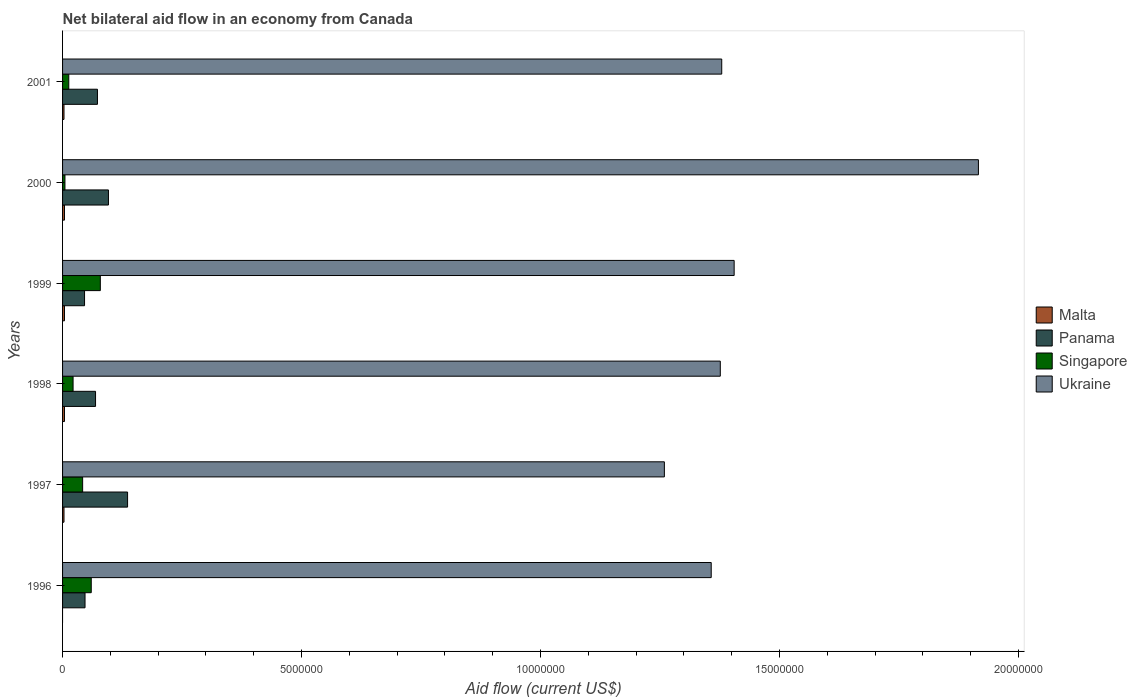How many different coloured bars are there?
Your answer should be very brief. 4. Are the number of bars per tick equal to the number of legend labels?
Keep it short and to the point. No. How many bars are there on the 4th tick from the bottom?
Your answer should be compact. 4. What is the label of the 3rd group of bars from the top?
Ensure brevity in your answer.  1999. Across all years, what is the minimum net bilateral aid flow in Ukraine?
Make the answer very short. 1.26e+07. What is the total net bilateral aid flow in Ukraine in the graph?
Make the answer very short. 8.69e+07. What is the difference between the net bilateral aid flow in Panama in 1996 and the net bilateral aid flow in Malta in 2000?
Make the answer very short. 4.30e+05. In the year 1998, what is the difference between the net bilateral aid flow in Ukraine and net bilateral aid flow in Panama?
Your answer should be very brief. 1.31e+07. In how many years, is the net bilateral aid flow in Malta greater than 4000000 US$?
Offer a very short reply. 0. What is the ratio of the net bilateral aid flow in Ukraine in 1999 to that in 2000?
Give a very brief answer. 0.73. Is the net bilateral aid flow in Malta in 1997 less than that in 1999?
Ensure brevity in your answer.  Yes. What is the difference between the highest and the lowest net bilateral aid flow in Panama?
Offer a very short reply. 9.00e+05. Is it the case that in every year, the sum of the net bilateral aid flow in Panama and net bilateral aid flow in Malta is greater than the sum of net bilateral aid flow in Ukraine and net bilateral aid flow in Singapore?
Make the answer very short. No. Is it the case that in every year, the sum of the net bilateral aid flow in Ukraine and net bilateral aid flow in Singapore is greater than the net bilateral aid flow in Malta?
Offer a terse response. Yes. Are all the bars in the graph horizontal?
Keep it short and to the point. Yes. How many years are there in the graph?
Your answer should be very brief. 6. Does the graph contain any zero values?
Give a very brief answer. Yes. Does the graph contain grids?
Your response must be concise. No. How are the legend labels stacked?
Provide a short and direct response. Vertical. What is the title of the graph?
Make the answer very short. Net bilateral aid flow in an economy from Canada. Does "Panama" appear as one of the legend labels in the graph?
Offer a terse response. Yes. What is the label or title of the X-axis?
Make the answer very short. Aid flow (current US$). What is the label or title of the Y-axis?
Your answer should be compact. Years. What is the Aid flow (current US$) of Malta in 1996?
Make the answer very short. 0. What is the Aid flow (current US$) of Panama in 1996?
Your response must be concise. 4.70e+05. What is the Aid flow (current US$) in Singapore in 1996?
Keep it short and to the point. 6.00e+05. What is the Aid flow (current US$) of Ukraine in 1996?
Your response must be concise. 1.36e+07. What is the Aid flow (current US$) of Malta in 1997?
Ensure brevity in your answer.  3.00e+04. What is the Aid flow (current US$) of Panama in 1997?
Provide a succinct answer. 1.36e+06. What is the Aid flow (current US$) in Singapore in 1997?
Provide a short and direct response. 4.20e+05. What is the Aid flow (current US$) of Ukraine in 1997?
Your answer should be very brief. 1.26e+07. What is the Aid flow (current US$) of Panama in 1998?
Your answer should be compact. 6.90e+05. What is the Aid flow (current US$) in Ukraine in 1998?
Offer a very short reply. 1.38e+07. What is the Aid flow (current US$) in Panama in 1999?
Make the answer very short. 4.60e+05. What is the Aid flow (current US$) of Singapore in 1999?
Your answer should be very brief. 7.90e+05. What is the Aid flow (current US$) in Ukraine in 1999?
Ensure brevity in your answer.  1.40e+07. What is the Aid flow (current US$) of Panama in 2000?
Your answer should be very brief. 9.60e+05. What is the Aid flow (current US$) in Ukraine in 2000?
Make the answer very short. 1.92e+07. What is the Aid flow (current US$) in Panama in 2001?
Ensure brevity in your answer.  7.30e+05. What is the Aid flow (current US$) in Ukraine in 2001?
Offer a terse response. 1.38e+07. Across all years, what is the maximum Aid flow (current US$) of Malta?
Provide a short and direct response. 4.00e+04. Across all years, what is the maximum Aid flow (current US$) in Panama?
Your response must be concise. 1.36e+06. Across all years, what is the maximum Aid flow (current US$) of Singapore?
Offer a terse response. 7.90e+05. Across all years, what is the maximum Aid flow (current US$) of Ukraine?
Provide a succinct answer. 1.92e+07. Across all years, what is the minimum Aid flow (current US$) of Malta?
Ensure brevity in your answer.  0. Across all years, what is the minimum Aid flow (current US$) of Panama?
Offer a terse response. 4.60e+05. Across all years, what is the minimum Aid flow (current US$) of Singapore?
Your answer should be compact. 5.00e+04. Across all years, what is the minimum Aid flow (current US$) in Ukraine?
Provide a short and direct response. 1.26e+07. What is the total Aid flow (current US$) in Malta in the graph?
Provide a short and direct response. 1.80e+05. What is the total Aid flow (current US$) of Panama in the graph?
Provide a short and direct response. 4.67e+06. What is the total Aid flow (current US$) of Singapore in the graph?
Provide a succinct answer. 2.21e+06. What is the total Aid flow (current US$) of Ukraine in the graph?
Offer a very short reply. 8.69e+07. What is the difference between the Aid flow (current US$) of Panama in 1996 and that in 1997?
Keep it short and to the point. -8.90e+05. What is the difference between the Aid flow (current US$) in Singapore in 1996 and that in 1997?
Ensure brevity in your answer.  1.80e+05. What is the difference between the Aid flow (current US$) of Ukraine in 1996 and that in 1997?
Ensure brevity in your answer.  9.80e+05. What is the difference between the Aid flow (current US$) in Panama in 1996 and that in 1998?
Your answer should be compact. -2.20e+05. What is the difference between the Aid flow (current US$) in Singapore in 1996 and that in 1998?
Give a very brief answer. 3.80e+05. What is the difference between the Aid flow (current US$) of Singapore in 1996 and that in 1999?
Keep it short and to the point. -1.90e+05. What is the difference between the Aid flow (current US$) in Ukraine in 1996 and that in 1999?
Offer a terse response. -4.80e+05. What is the difference between the Aid flow (current US$) in Panama in 1996 and that in 2000?
Your answer should be compact. -4.90e+05. What is the difference between the Aid flow (current US$) in Singapore in 1996 and that in 2000?
Ensure brevity in your answer.  5.50e+05. What is the difference between the Aid flow (current US$) of Ukraine in 1996 and that in 2000?
Offer a terse response. -5.59e+06. What is the difference between the Aid flow (current US$) of Malta in 1997 and that in 1998?
Keep it short and to the point. -10000. What is the difference between the Aid flow (current US$) in Panama in 1997 and that in 1998?
Your answer should be compact. 6.70e+05. What is the difference between the Aid flow (current US$) in Ukraine in 1997 and that in 1998?
Keep it short and to the point. -1.17e+06. What is the difference between the Aid flow (current US$) of Panama in 1997 and that in 1999?
Keep it short and to the point. 9.00e+05. What is the difference between the Aid flow (current US$) in Singapore in 1997 and that in 1999?
Give a very brief answer. -3.70e+05. What is the difference between the Aid flow (current US$) in Ukraine in 1997 and that in 1999?
Ensure brevity in your answer.  -1.46e+06. What is the difference between the Aid flow (current US$) of Panama in 1997 and that in 2000?
Your response must be concise. 4.00e+05. What is the difference between the Aid flow (current US$) in Singapore in 1997 and that in 2000?
Keep it short and to the point. 3.70e+05. What is the difference between the Aid flow (current US$) in Ukraine in 1997 and that in 2000?
Your answer should be very brief. -6.57e+06. What is the difference between the Aid flow (current US$) of Malta in 1997 and that in 2001?
Provide a succinct answer. 0. What is the difference between the Aid flow (current US$) of Panama in 1997 and that in 2001?
Ensure brevity in your answer.  6.30e+05. What is the difference between the Aid flow (current US$) of Singapore in 1997 and that in 2001?
Ensure brevity in your answer.  2.90e+05. What is the difference between the Aid flow (current US$) of Ukraine in 1997 and that in 2001?
Your response must be concise. -1.20e+06. What is the difference between the Aid flow (current US$) in Singapore in 1998 and that in 1999?
Your response must be concise. -5.70e+05. What is the difference between the Aid flow (current US$) of Ukraine in 1998 and that in 1999?
Make the answer very short. -2.90e+05. What is the difference between the Aid flow (current US$) of Malta in 1998 and that in 2000?
Your answer should be very brief. 0. What is the difference between the Aid flow (current US$) of Ukraine in 1998 and that in 2000?
Ensure brevity in your answer.  -5.40e+06. What is the difference between the Aid flow (current US$) in Malta in 1998 and that in 2001?
Ensure brevity in your answer.  10000. What is the difference between the Aid flow (current US$) in Singapore in 1998 and that in 2001?
Offer a very short reply. 9.00e+04. What is the difference between the Aid flow (current US$) in Panama in 1999 and that in 2000?
Ensure brevity in your answer.  -5.00e+05. What is the difference between the Aid flow (current US$) of Singapore in 1999 and that in 2000?
Provide a short and direct response. 7.40e+05. What is the difference between the Aid flow (current US$) in Ukraine in 1999 and that in 2000?
Offer a very short reply. -5.11e+06. What is the difference between the Aid flow (current US$) in Malta in 1999 and that in 2001?
Offer a terse response. 10000. What is the difference between the Aid flow (current US$) in Ukraine in 1999 and that in 2001?
Make the answer very short. 2.60e+05. What is the difference between the Aid flow (current US$) of Singapore in 2000 and that in 2001?
Ensure brevity in your answer.  -8.00e+04. What is the difference between the Aid flow (current US$) of Ukraine in 2000 and that in 2001?
Give a very brief answer. 5.37e+06. What is the difference between the Aid flow (current US$) in Panama in 1996 and the Aid flow (current US$) in Singapore in 1997?
Give a very brief answer. 5.00e+04. What is the difference between the Aid flow (current US$) of Panama in 1996 and the Aid flow (current US$) of Ukraine in 1997?
Keep it short and to the point. -1.21e+07. What is the difference between the Aid flow (current US$) of Singapore in 1996 and the Aid flow (current US$) of Ukraine in 1997?
Keep it short and to the point. -1.20e+07. What is the difference between the Aid flow (current US$) in Panama in 1996 and the Aid flow (current US$) in Singapore in 1998?
Your answer should be very brief. 2.50e+05. What is the difference between the Aid flow (current US$) of Panama in 1996 and the Aid flow (current US$) of Ukraine in 1998?
Your answer should be very brief. -1.33e+07. What is the difference between the Aid flow (current US$) in Singapore in 1996 and the Aid flow (current US$) in Ukraine in 1998?
Offer a terse response. -1.32e+07. What is the difference between the Aid flow (current US$) in Panama in 1996 and the Aid flow (current US$) in Singapore in 1999?
Offer a terse response. -3.20e+05. What is the difference between the Aid flow (current US$) in Panama in 1996 and the Aid flow (current US$) in Ukraine in 1999?
Offer a very short reply. -1.36e+07. What is the difference between the Aid flow (current US$) of Singapore in 1996 and the Aid flow (current US$) of Ukraine in 1999?
Offer a terse response. -1.34e+07. What is the difference between the Aid flow (current US$) of Panama in 1996 and the Aid flow (current US$) of Ukraine in 2000?
Your answer should be compact. -1.87e+07. What is the difference between the Aid flow (current US$) of Singapore in 1996 and the Aid flow (current US$) of Ukraine in 2000?
Provide a short and direct response. -1.86e+07. What is the difference between the Aid flow (current US$) in Panama in 1996 and the Aid flow (current US$) in Singapore in 2001?
Offer a terse response. 3.40e+05. What is the difference between the Aid flow (current US$) of Panama in 1996 and the Aid flow (current US$) of Ukraine in 2001?
Give a very brief answer. -1.33e+07. What is the difference between the Aid flow (current US$) of Singapore in 1996 and the Aid flow (current US$) of Ukraine in 2001?
Offer a terse response. -1.32e+07. What is the difference between the Aid flow (current US$) of Malta in 1997 and the Aid flow (current US$) of Panama in 1998?
Give a very brief answer. -6.60e+05. What is the difference between the Aid flow (current US$) in Malta in 1997 and the Aid flow (current US$) in Singapore in 1998?
Offer a very short reply. -1.90e+05. What is the difference between the Aid flow (current US$) in Malta in 1997 and the Aid flow (current US$) in Ukraine in 1998?
Provide a short and direct response. -1.37e+07. What is the difference between the Aid flow (current US$) in Panama in 1997 and the Aid flow (current US$) in Singapore in 1998?
Your response must be concise. 1.14e+06. What is the difference between the Aid flow (current US$) of Panama in 1997 and the Aid flow (current US$) of Ukraine in 1998?
Give a very brief answer. -1.24e+07. What is the difference between the Aid flow (current US$) in Singapore in 1997 and the Aid flow (current US$) in Ukraine in 1998?
Your answer should be compact. -1.33e+07. What is the difference between the Aid flow (current US$) in Malta in 1997 and the Aid flow (current US$) in Panama in 1999?
Keep it short and to the point. -4.30e+05. What is the difference between the Aid flow (current US$) in Malta in 1997 and the Aid flow (current US$) in Singapore in 1999?
Your answer should be very brief. -7.60e+05. What is the difference between the Aid flow (current US$) of Malta in 1997 and the Aid flow (current US$) of Ukraine in 1999?
Offer a very short reply. -1.40e+07. What is the difference between the Aid flow (current US$) of Panama in 1997 and the Aid flow (current US$) of Singapore in 1999?
Give a very brief answer. 5.70e+05. What is the difference between the Aid flow (current US$) of Panama in 1997 and the Aid flow (current US$) of Ukraine in 1999?
Your answer should be compact. -1.27e+07. What is the difference between the Aid flow (current US$) of Singapore in 1997 and the Aid flow (current US$) of Ukraine in 1999?
Provide a succinct answer. -1.36e+07. What is the difference between the Aid flow (current US$) of Malta in 1997 and the Aid flow (current US$) of Panama in 2000?
Your answer should be very brief. -9.30e+05. What is the difference between the Aid flow (current US$) of Malta in 1997 and the Aid flow (current US$) of Singapore in 2000?
Your answer should be compact. -2.00e+04. What is the difference between the Aid flow (current US$) in Malta in 1997 and the Aid flow (current US$) in Ukraine in 2000?
Provide a short and direct response. -1.91e+07. What is the difference between the Aid flow (current US$) in Panama in 1997 and the Aid flow (current US$) in Singapore in 2000?
Provide a short and direct response. 1.31e+06. What is the difference between the Aid flow (current US$) of Panama in 1997 and the Aid flow (current US$) of Ukraine in 2000?
Give a very brief answer. -1.78e+07. What is the difference between the Aid flow (current US$) in Singapore in 1997 and the Aid flow (current US$) in Ukraine in 2000?
Provide a short and direct response. -1.87e+07. What is the difference between the Aid flow (current US$) in Malta in 1997 and the Aid flow (current US$) in Panama in 2001?
Provide a short and direct response. -7.00e+05. What is the difference between the Aid flow (current US$) of Malta in 1997 and the Aid flow (current US$) of Ukraine in 2001?
Ensure brevity in your answer.  -1.38e+07. What is the difference between the Aid flow (current US$) of Panama in 1997 and the Aid flow (current US$) of Singapore in 2001?
Your answer should be very brief. 1.23e+06. What is the difference between the Aid flow (current US$) of Panama in 1997 and the Aid flow (current US$) of Ukraine in 2001?
Your response must be concise. -1.24e+07. What is the difference between the Aid flow (current US$) of Singapore in 1997 and the Aid flow (current US$) of Ukraine in 2001?
Give a very brief answer. -1.34e+07. What is the difference between the Aid flow (current US$) of Malta in 1998 and the Aid flow (current US$) of Panama in 1999?
Make the answer very short. -4.20e+05. What is the difference between the Aid flow (current US$) of Malta in 1998 and the Aid flow (current US$) of Singapore in 1999?
Your answer should be very brief. -7.50e+05. What is the difference between the Aid flow (current US$) in Malta in 1998 and the Aid flow (current US$) in Ukraine in 1999?
Your answer should be very brief. -1.40e+07. What is the difference between the Aid flow (current US$) of Panama in 1998 and the Aid flow (current US$) of Ukraine in 1999?
Make the answer very short. -1.34e+07. What is the difference between the Aid flow (current US$) in Singapore in 1998 and the Aid flow (current US$) in Ukraine in 1999?
Offer a terse response. -1.38e+07. What is the difference between the Aid flow (current US$) in Malta in 1998 and the Aid flow (current US$) in Panama in 2000?
Your answer should be compact. -9.20e+05. What is the difference between the Aid flow (current US$) in Malta in 1998 and the Aid flow (current US$) in Singapore in 2000?
Offer a terse response. -10000. What is the difference between the Aid flow (current US$) of Malta in 1998 and the Aid flow (current US$) of Ukraine in 2000?
Offer a terse response. -1.91e+07. What is the difference between the Aid flow (current US$) in Panama in 1998 and the Aid flow (current US$) in Singapore in 2000?
Provide a succinct answer. 6.40e+05. What is the difference between the Aid flow (current US$) in Panama in 1998 and the Aid flow (current US$) in Ukraine in 2000?
Provide a succinct answer. -1.85e+07. What is the difference between the Aid flow (current US$) of Singapore in 1998 and the Aid flow (current US$) of Ukraine in 2000?
Offer a very short reply. -1.89e+07. What is the difference between the Aid flow (current US$) in Malta in 1998 and the Aid flow (current US$) in Panama in 2001?
Ensure brevity in your answer.  -6.90e+05. What is the difference between the Aid flow (current US$) in Malta in 1998 and the Aid flow (current US$) in Singapore in 2001?
Offer a terse response. -9.00e+04. What is the difference between the Aid flow (current US$) in Malta in 1998 and the Aid flow (current US$) in Ukraine in 2001?
Ensure brevity in your answer.  -1.38e+07. What is the difference between the Aid flow (current US$) in Panama in 1998 and the Aid flow (current US$) in Singapore in 2001?
Make the answer very short. 5.60e+05. What is the difference between the Aid flow (current US$) of Panama in 1998 and the Aid flow (current US$) of Ukraine in 2001?
Your answer should be compact. -1.31e+07. What is the difference between the Aid flow (current US$) in Singapore in 1998 and the Aid flow (current US$) in Ukraine in 2001?
Keep it short and to the point. -1.36e+07. What is the difference between the Aid flow (current US$) in Malta in 1999 and the Aid flow (current US$) in Panama in 2000?
Make the answer very short. -9.20e+05. What is the difference between the Aid flow (current US$) in Malta in 1999 and the Aid flow (current US$) in Ukraine in 2000?
Provide a succinct answer. -1.91e+07. What is the difference between the Aid flow (current US$) in Panama in 1999 and the Aid flow (current US$) in Ukraine in 2000?
Your answer should be very brief. -1.87e+07. What is the difference between the Aid flow (current US$) in Singapore in 1999 and the Aid flow (current US$) in Ukraine in 2000?
Your answer should be compact. -1.84e+07. What is the difference between the Aid flow (current US$) in Malta in 1999 and the Aid flow (current US$) in Panama in 2001?
Your answer should be very brief. -6.90e+05. What is the difference between the Aid flow (current US$) of Malta in 1999 and the Aid flow (current US$) of Singapore in 2001?
Give a very brief answer. -9.00e+04. What is the difference between the Aid flow (current US$) in Malta in 1999 and the Aid flow (current US$) in Ukraine in 2001?
Provide a succinct answer. -1.38e+07. What is the difference between the Aid flow (current US$) of Panama in 1999 and the Aid flow (current US$) of Ukraine in 2001?
Your answer should be compact. -1.33e+07. What is the difference between the Aid flow (current US$) in Singapore in 1999 and the Aid flow (current US$) in Ukraine in 2001?
Provide a short and direct response. -1.30e+07. What is the difference between the Aid flow (current US$) of Malta in 2000 and the Aid flow (current US$) of Panama in 2001?
Make the answer very short. -6.90e+05. What is the difference between the Aid flow (current US$) in Malta in 2000 and the Aid flow (current US$) in Ukraine in 2001?
Offer a very short reply. -1.38e+07. What is the difference between the Aid flow (current US$) in Panama in 2000 and the Aid flow (current US$) in Singapore in 2001?
Your response must be concise. 8.30e+05. What is the difference between the Aid flow (current US$) of Panama in 2000 and the Aid flow (current US$) of Ukraine in 2001?
Offer a terse response. -1.28e+07. What is the difference between the Aid flow (current US$) of Singapore in 2000 and the Aid flow (current US$) of Ukraine in 2001?
Make the answer very short. -1.37e+07. What is the average Aid flow (current US$) of Malta per year?
Your response must be concise. 3.00e+04. What is the average Aid flow (current US$) in Panama per year?
Your response must be concise. 7.78e+05. What is the average Aid flow (current US$) of Singapore per year?
Your response must be concise. 3.68e+05. What is the average Aid flow (current US$) of Ukraine per year?
Your answer should be compact. 1.45e+07. In the year 1996, what is the difference between the Aid flow (current US$) of Panama and Aid flow (current US$) of Singapore?
Ensure brevity in your answer.  -1.30e+05. In the year 1996, what is the difference between the Aid flow (current US$) in Panama and Aid flow (current US$) in Ukraine?
Make the answer very short. -1.31e+07. In the year 1996, what is the difference between the Aid flow (current US$) of Singapore and Aid flow (current US$) of Ukraine?
Offer a terse response. -1.30e+07. In the year 1997, what is the difference between the Aid flow (current US$) of Malta and Aid flow (current US$) of Panama?
Provide a short and direct response. -1.33e+06. In the year 1997, what is the difference between the Aid flow (current US$) in Malta and Aid flow (current US$) in Singapore?
Give a very brief answer. -3.90e+05. In the year 1997, what is the difference between the Aid flow (current US$) in Malta and Aid flow (current US$) in Ukraine?
Offer a terse response. -1.26e+07. In the year 1997, what is the difference between the Aid flow (current US$) of Panama and Aid flow (current US$) of Singapore?
Ensure brevity in your answer.  9.40e+05. In the year 1997, what is the difference between the Aid flow (current US$) of Panama and Aid flow (current US$) of Ukraine?
Keep it short and to the point. -1.12e+07. In the year 1997, what is the difference between the Aid flow (current US$) of Singapore and Aid flow (current US$) of Ukraine?
Make the answer very short. -1.22e+07. In the year 1998, what is the difference between the Aid flow (current US$) in Malta and Aid flow (current US$) in Panama?
Offer a terse response. -6.50e+05. In the year 1998, what is the difference between the Aid flow (current US$) in Malta and Aid flow (current US$) in Ukraine?
Offer a very short reply. -1.37e+07. In the year 1998, what is the difference between the Aid flow (current US$) in Panama and Aid flow (current US$) in Ukraine?
Ensure brevity in your answer.  -1.31e+07. In the year 1998, what is the difference between the Aid flow (current US$) in Singapore and Aid flow (current US$) in Ukraine?
Ensure brevity in your answer.  -1.35e+07. In the year 1999, what is the difference between the Aid flow (current US$) in Malta and Aid flow (current US$) in Panama?
Ensure brevity in your answer.  -4.20e+05. In the year 1999, what is the difference between the Aid flow (current US$) in Malta and Aid flow (current US$) in Singapore?
Offer a terse response. -7.50e+05. In the year 1999, what is the difference between the Aid flow (current US$) in Malta and Aid flow (current US$) in Ukraine?
Provide a succinct answer. -1.40e+07. In the year 1999, what is the difference between the Aid flow (current US$) of Panama and Aid flow (current US$) of Singapore?
Your answer should be very brief. -3.30e+05. In the year 1999, what is the difference between the Aid flow (current US$) of Panama and Aid flow (current US$) of Ukraine?
Your answer should be very brief. -1.36e+07. In the year 1999, what is the difference between the Aid flow (current US$) in Singapore and Aid flow (current US$) in Ukraine?
Offer a terse response. -1.33e+07. In the year 2000, what is the difference between the Aid flow (current US$) in Malta and Aid flow (current US$) in Panama?
Make the answer very short. -9.20e+05. In the year 2000, what is the difference between the Aid flow (current US$) in Malta and Aid flow (current US$) in Singapore?
Your answer should be very brief. -10000. In the year 2000, what is the difference between the Aid flow (current US$) of Malta and Aid flow (current US$) of Ukraine?
Make the answer very short. -1.91e+07. In the year 2000, what is the difference between the Aid flow (current US$) of Panama and Aid flow (current US$) of Singapore?
Offer a terse response. 9.10e+05. In the year 2000, what is the difference between the Aid flow (current US$) of Panama and Aid flow (current US$) of Ukraine?
Provide a short and direct response. -1.82e+07. In the year 2000, what is the difference between the Aid flow (current US$) in Singapore and Aid flow (current US$) in Ukraine?
Offer a very short reply. -1.91e+07. In the year 2001, what is the difference between the Aid flow (current US$) in Malta and Aid flow (current US$) in Panama?
Provide a succinct answer. -7.00e+05. In the year 2001, what is the difference between the Aid flow (current US$) of Malta and Aid flow (current US$) of Ukraine?
Offer a very short reply. -1.38e+07. In the year 2001, what is the difference between the Aid flow (current US$) in Panama and Aid flow (current US$) in Singapore?
Ensure brevity in your answer.  6.00e+05. In the year 2001, what is the difference between the Aid flow (current US$) in Panama and Aid flow (current US$) in Ukraine?
Your response must be concise. -1.31e+07. In the year 2001, what is the difference between the Aid flow (current US$) of Singapore and Aid flow (current US$) of Ukraine?
Your answer should be compact. -1.37e+07. What is the ratio of the Aid flow (current US$) in Panama in 1996 to that in 1997?
Provide a short and direct response. 0.35. What is the ratio of the Aid flow (current US$) of Singapore in 1996 to that in 1997?
Your answer should be compact. 1.43. What is the ratio of the Aid flow (current US$) of Ukraine in 1996 to that in 1997?
Give a very brief answer. 1.08. What is the ratio of the Aid flow (current US$) of Panama in 1996 to that in 1998?
Ensure brevity in your answer.  0.68. What is the ratio of the Aid flow (current US$) in Singapore in 1996 to that in 1998?
Keep it short and to the point. 2.73. What is the ratio of the Aid flow (current US$) of Ukraine in 1996 to that in 1998?
Your answer should be very brief. 0.99. What is the ratio of the Aid flow (current US$) of Panama in 1996 to that in 1999?
Provide a short and direct response. 1.02. What is the ratio of the Aid flow (current US$) in Singapore in 1996 to that in 1999?
Provide a succinct answer. 0.76. What is the ratio of the Aid flow (current US$) of Ukraine in 1996 to that in 1999?
Keep it short and to the point. 0.97. What is the ratio of the Aid flow (current US$) in Panama in 1996 to that in 2000?
Offer a very short reply. 0.49. What is the ratio of the Aid flow (current US$) of Singapore in 1996 to that in 2000?
Your response must be concise. 12. What is the ratio of the Aid flow (current US$) in Ukraine in 1996 to that in 2000?
Give a very brief answer. 0.71. What is the ratio of the Aid flow (current US$) in Panama in 1996 to that in 2001?
Provide a succinct answer. 0.64. What is the ratio of the Aid flow (current US$) in Singapore in 1996 to that in 2001?
Provide a short and direct response. 4.62. What is the ratio of the Aid flow (current US$) in Panama in 1997 to that in 1998?
Your response must be concise. 1.97. What is the ratio of the Aid flow (current US$) of Singapore in 1997 to that in 1998?
Give a very brief answer. 1.91. What is the ratio of the Aid flow (current US$) of Ukraine in 1997 to that in 1998?
Keep it short and to the point. 0.92. What is the ratio of the Aid flow (current US$) of Panama in 1997 to that in 1999?
Make the answer very short. 2.96. What is the ratio of the Aid flow (current US$) of Singapore in 1997 to that in 1999?
Offer a terse response. 0.53. What is the ratio of the Aid flow (current US$) of Ukraine in 1997 to that in 1999?
Offer a terse response. 0.9. What is the ratio of the Aid flow (current US$) of Panama in 1997 to that in 2000?
Your response must be concise. 1.42. What is the ratio of the Aid flow (current US$) in Singapore in 1997 to that in 2000?
Your answer should be compact. 8.4. What is the ratio of the Aid flow (current US$) in Ukraine in 1997 to that in 2000?
Your answer should be very brief. 0.66. What is the ratio of the Aid flow (current US$) of Panama in 1997 to that in 2001?
Your answer should be compact. 1.86. What is the ratio of the Aid flow (current US$) in Singapore in 1997 to that in 2001?
Provide a succinct answer. 3.23. What is the ratio of the Aid flow (current US$) of Malta in 1998 to that in 1999?
Your answer should be very brief. 1. What is the ratio of the Aid flow (current US$) of Panama in 1998 to that in 1999?
Give a very brief answer. 1.5. What is the ratio of the Aid flow (current US$) in Singapore in 1998 to that in 1999?
Make the answer very short. 0.28. What is the ratio of the Aid flow (current US$) of Ukraine in 1998 to that in 1999?
Ensure brevity in your answer.  0.98. What is the ratio of the Aid flow (current US$) of Malta in 1998 to that in 2000?
Ensure brevity in your answer.  1. What is the ratio of the Aid flow (current US$) of Panama in 1998 to that in 2000?
Your answer should be compact. 0.72. What is the ratio of the Aid flow (current US$) of Singapore in 1998 to that in 2000?
Make the answer very short. 4.4. What is the ratio of the Aid flow (current US$) in Ukraine in 1998 to that in 2000?
Your answer should be compact. 0.72. What is the ratio of the Aid flow (current US$) in Malta in 1998 to that in 2001?
Your answer should be compact. 1.33. What is the ratio of the Aid flow (current US$) in Panama in 1998 to that in 2001?
Make the answer very short. 0.95. What is the ratio of the Aid flow (current US$) in Singapore in 1998 to that in 2001?
Make the answer very short. 1.69. What is the ratio of the Aid flow (current US$) of Ukraine in 1998 to that in 2001?
Your answer should be compact. 1. What is the ratio of the Aid flow (current US$) in Panama in 1999 to that in 2000?
Provide a short and direct response. 0.48. What is the ratio of the Aid flow (current US$) of Ukraine in 1999 to that in 2000?
Ensure brevity in your answer.  0.73. What is the ratio of the Aid flow (current US$) of Malta in 1999 to that in 2001?
Your response must be concise. 1.33. What is the ratio of the Aid flow (current US$) in Panama in 1999 to that in 2001?
Give a very brief answer. 0.63. What is the ratio of the Aid flow (current US$) of Singapore in 1999 to that in 2001?
Your answer should be very brief. 6.08. What is the ratio of the Aid flow (current US$) of Ukraine in 1999 to that in 2001?
Offer a terse response. 1.02. What is the ratio of the Aid flow (current US$) of Malta in 2000 to that in 2001?
Provide a succinct answer. 1.33. What is the ratio of the Aid flow (current US$) in Panama in 2000 to that in 2001?
Provide a short and direct response. 1.32. What is the ratio of the Aid flow (current US$) in Singapore in 2000 to that in 2001?
Provide a short and direct response. 0.38. What is the ratio of the Aid flow (current US$) in Ukraine in 2000 to that in 2001?
Ensure brevity in your answer.  1.39. What is the difference between the highest and the second highest Aid flow (current US$) of Malta?
Offer a terse response. 0. What is the difference between the highest and the second highest Aid flow (current US$) of Panama?
Offer a very short reply. 4.00e+05. What is the difference between the highest and the second highest Aid flow (current US$) of Ukraine?
Make the answer very short. 5.11e+06. What is the difference between the highest and the lowest Aid flow (current US$) in Panama?
Offer a very short reply. 9.00e+05. What is the difference between the highest and the lowest Aid flow (current US$) of Singapore?
Your response must be concise. 7.40e+05. What is the difference between the highest and the lowest Aid flow (current US$) in Ukraine?
Provide a succinct answer. 6.57e+06. 